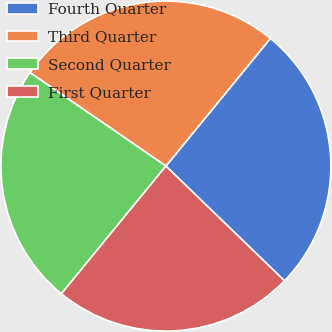<chart> <loc_0><loc_0><loc_500><loc_500><pie_chart><fcel>Fourth Quarter<fcel>Third Quarter<fcel>Second Quarter<fcel>First Quarter<nl><fcel>26.32%<fcel>26.32%<fcel>23.68%<fcel>23.68%<nl></chart> 